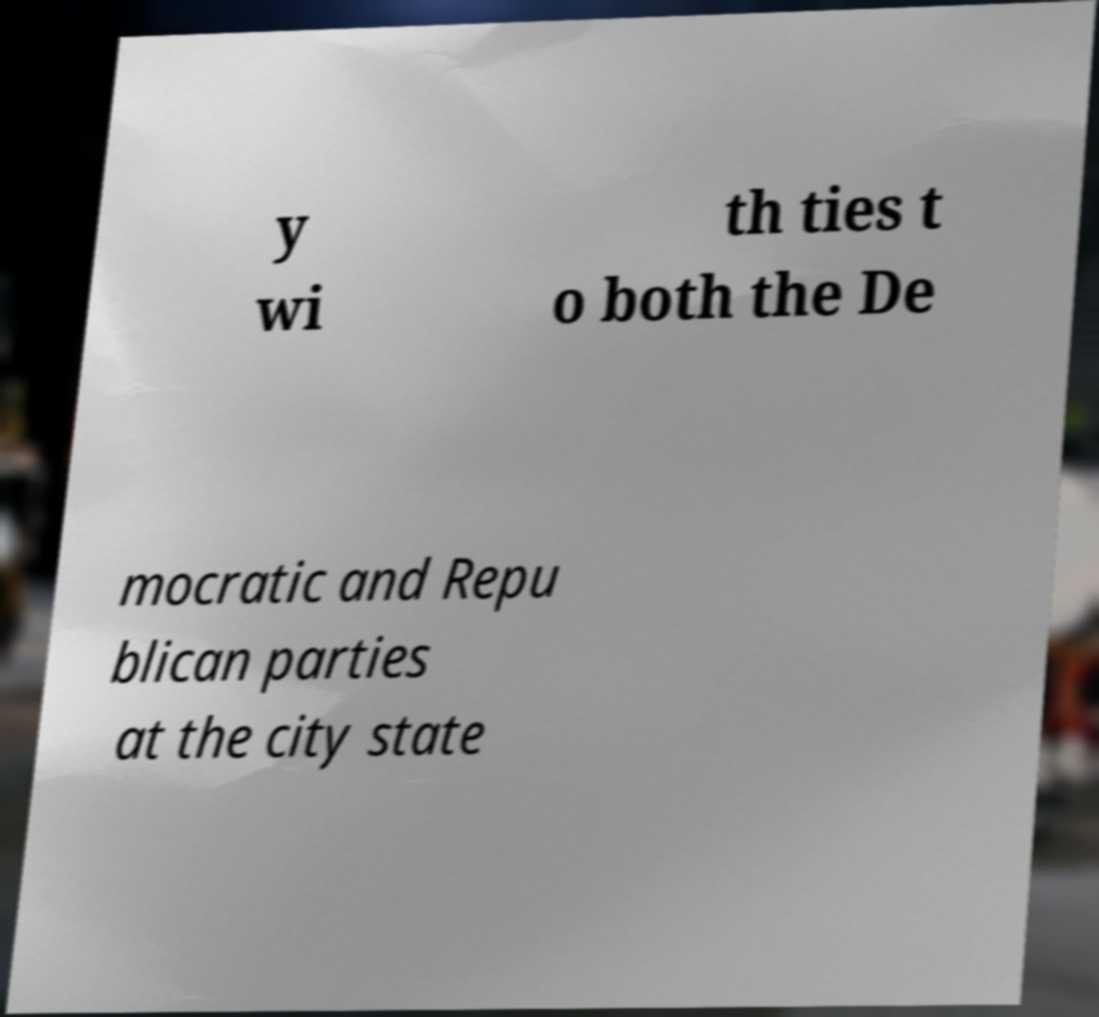For documentation purposes, I need the text within this image transcribed. Could you provide that? y wi th ties t o both the De mocratic and Repu blican parties at the city state 